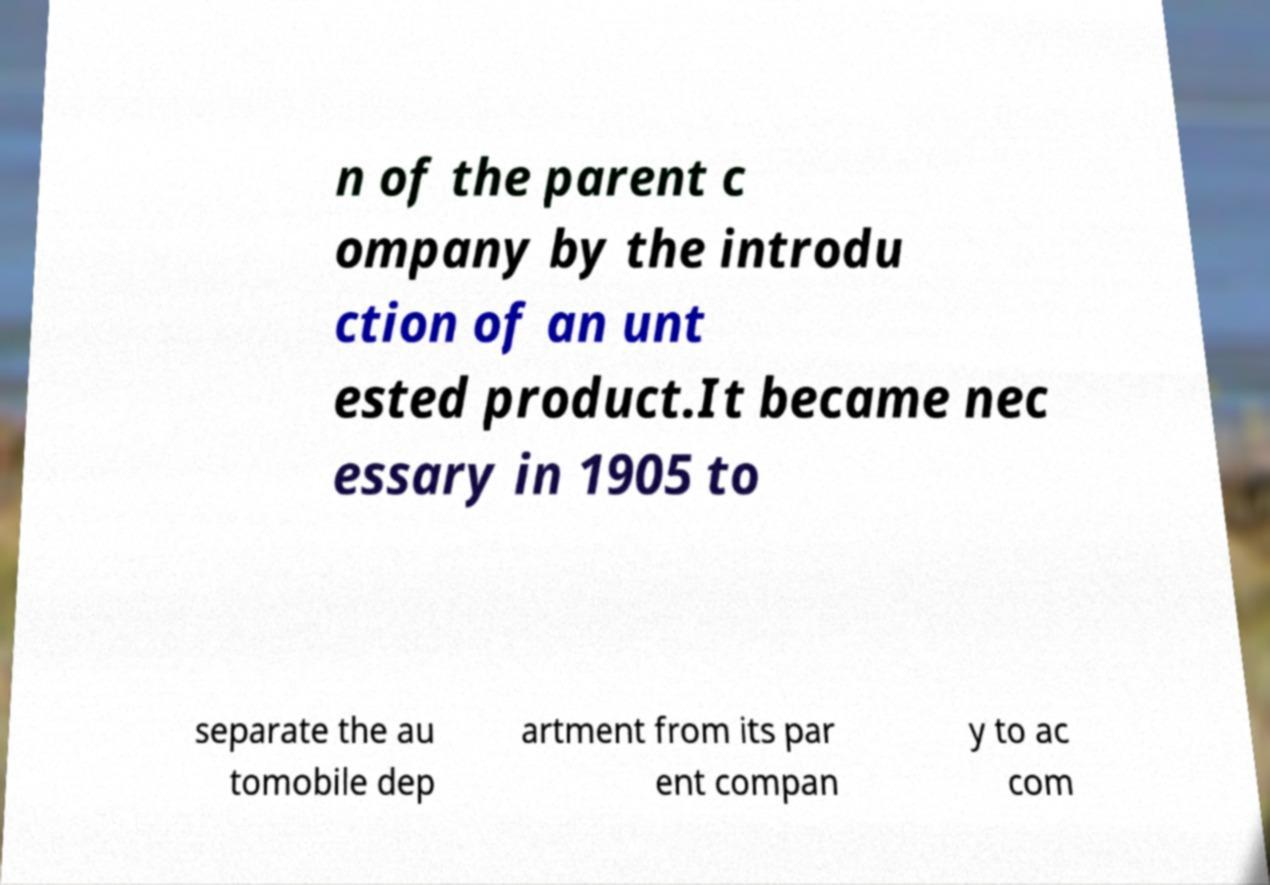For documentation purposes, I need the text within this image transcribed. Could you provide that? n of the parent c ompany by the introdu ction of an unt ested product.It became nec essary in 1905 to separate the au tomobile dep artment from its par ent compan y to ac com 